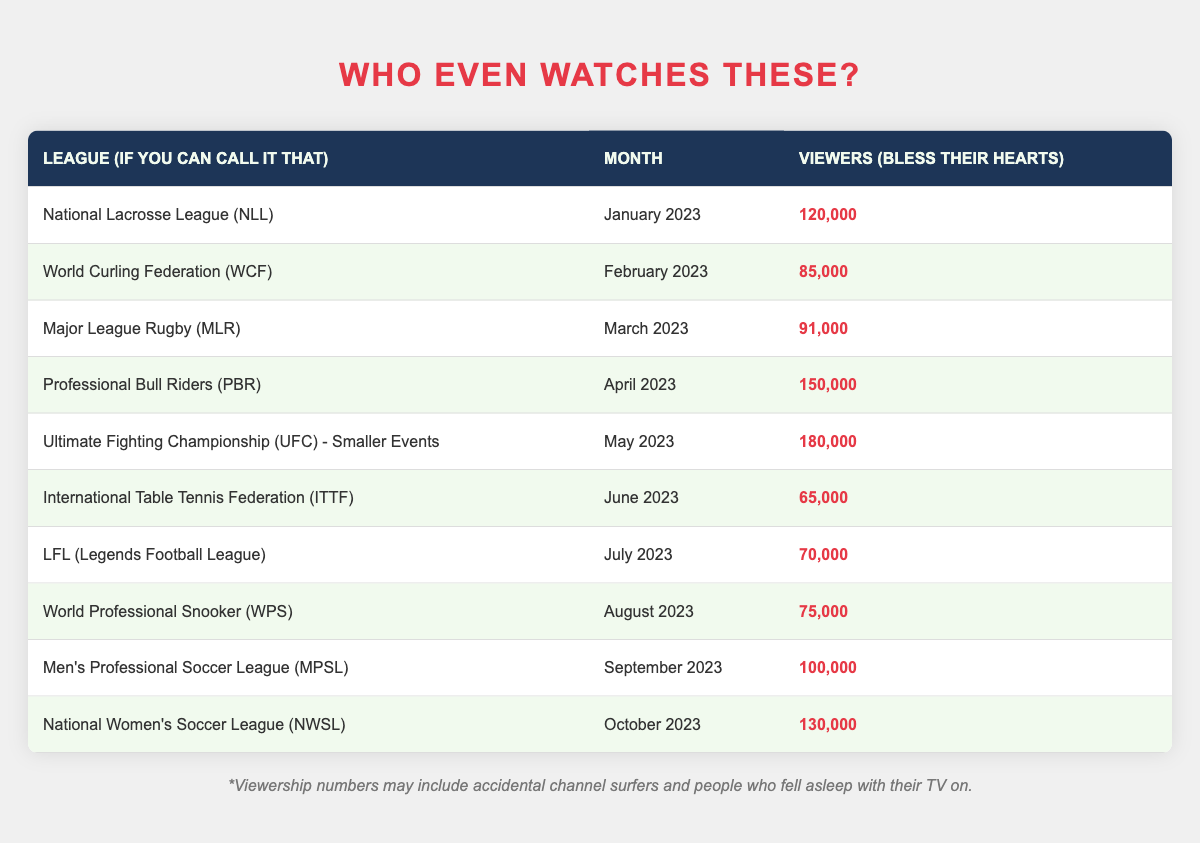What's the viewership for the Professional Bull Riders (PBR) in April 2023? Directly refer to the table, where PBR's viewership is listed as 150,000 in April 2023.
Answer: 150,000 In which month did the National Women's Soccer League (NWSL) have 130,000 viewers? The table shows that NWSL had 130,000 viewers in October 2023.
Answer: October 2023 Which league had the highest viewership, and what was the number? The highest viewership in the table is seen for Ultimate Fighting Championship (UFC) - Smaller Events with 180,000 viewers in May 2023.
Answer: UFC - Smaller Events; 180,000 What is the total viewership of the leagues listed in June and July 2023 combined? From the table, ITTF had 65,000 viewers in June and LFL had 70,000 viewers in July. Adding these gives 65,000 + 70,000 = 135,000.
Answer: 135,000 Is it true that less than 80,000 viewers watched the World Curling Federation (WCF) in February? According to the table, WCF had 85,000 viewers, which is not less than 80,000.
Answer: No Which league had viewership lower than 100,000 viewers and was outperformed by both the Major League Rugby (MLR) and Professional Bull Riders (PBR)? MLR had 91,000 viewers, and comparing this with PBR (150,000) confirms it is lower. Additionally, the International Table Tennis Federation (ITTF) had the lowest viewership at 65,000, also lower than MLR.
Answer: ITTF (65,000) Calculate the average viewership of leagues from January to March 2023. The viewers for NLL in January is 120,000, WCF in February is 85,000, and MLR in March is 91,000. The sum is 120,000 + 85,000 + 91,000 = 296,000. Dividing this by 3 gives an average of 296,000 / 3 = 98,666.67, which rounds to approximately 98,667.
Answer: 98,667 What month had the least viewership across all leagues listed? The least viewership is from the International Table Tennis Federation (ITTF) in June 2023 with 65,000 viewers, which is the lowest number shown in the table.
Answer: June 2023 